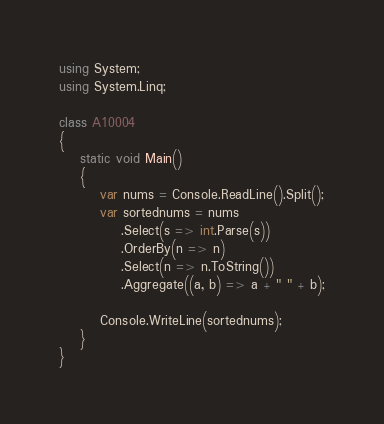Convert code to text. <code><loc_0><loc_0><loc_500><loc_500><_C#_>using System;
using System.Linq; 

class A10004
{
	static void Main()
	{
		var nums = Console.ReadLine().Split();
		var sortednums = nums
			.Select(s => int.Parse(s))
			.OrderBy(n => n)
			.Select(n => n.ToString())
			.Aggregate((a, b) => a + " " + b);

		Console.WriteLine(sortednums);
	}
}</code> 